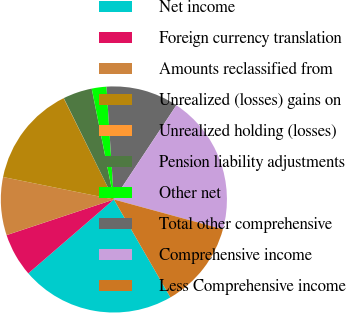Convert chart to OTSL. <chart><loc_0><loc_0><loc_500><loc_500><pie_chart><fcel>Net income<fcel>Foreign currency translation<fcel>Amounts reclassified from<fcel>Unrealized (losses) gains on<fcel>Unrealized holding (losses)<fcel>Pension liability adjustments<fcel>Other net<fcel>Total other comprehensive<fcel>Comprehensive income<fcel>Less Comprehensive income<nl><fcel>22.0%<fcel>6.23%<fcel>8.29%<fcel>14.49%<fcel>0.03%<fcel>4.16%<fcel>2.1%<fcel>10.36%<fcel>19.93%<fcel>12.42%<nl></chart> 